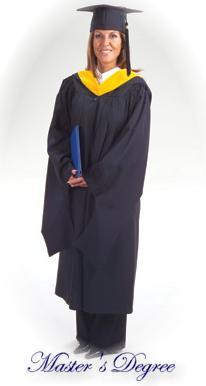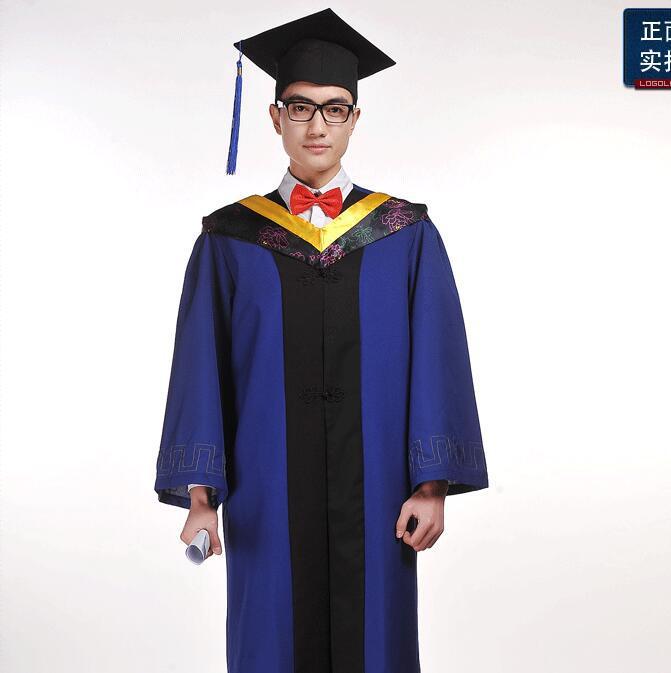The first image is the image on the left, the second image is the image on the right. Examine the images to the left and right. Is the description "An image shows a mannequin wearing a graduation robe with black stripes on its sleeves." accurate? Answer yes or no. No. 